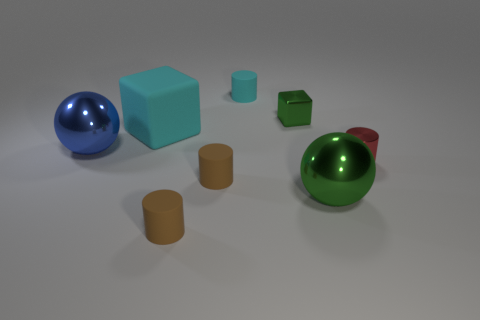What size is the cyan thing that is the same shape as the red metallic thing?
Offer a very short reply. Small. There is a rubber cylinder that is in front of the large sphere right of the tiny cyan rubber object; are there any rubber cylinders that are behind it?
Keep it short and to the point. Yes. What material is the block that is to the right of the large cyan rubber block?
Ensure brevity in your answer.  Metal. What number of tiny objects are cyan matte cylinders or brown matte cylinders?
Offer a very short reply. 3. There is a metallic thing that is in front of the red thing; is it the same size as the large blue metal object?
Your response must be concise. Yes. What number of other things are there of the same color as the tiny metal block?
Provide a succinct answer. 1. What is the material of the large cyan cube?
Your answer should be compact. Rubber. There is a tiny thing that is both on the right side of the cyan cylinder and in front of the small green block; what material is it made of?
Keep it short and to the point. Metal. What number of objects are tiny brown rubber cylinders behind the green sphere or big purple shiny objects?
Make the answer very short. 1. Is the color of the tiny metal block the same as the big matte block?
Your response must be concise. No. 